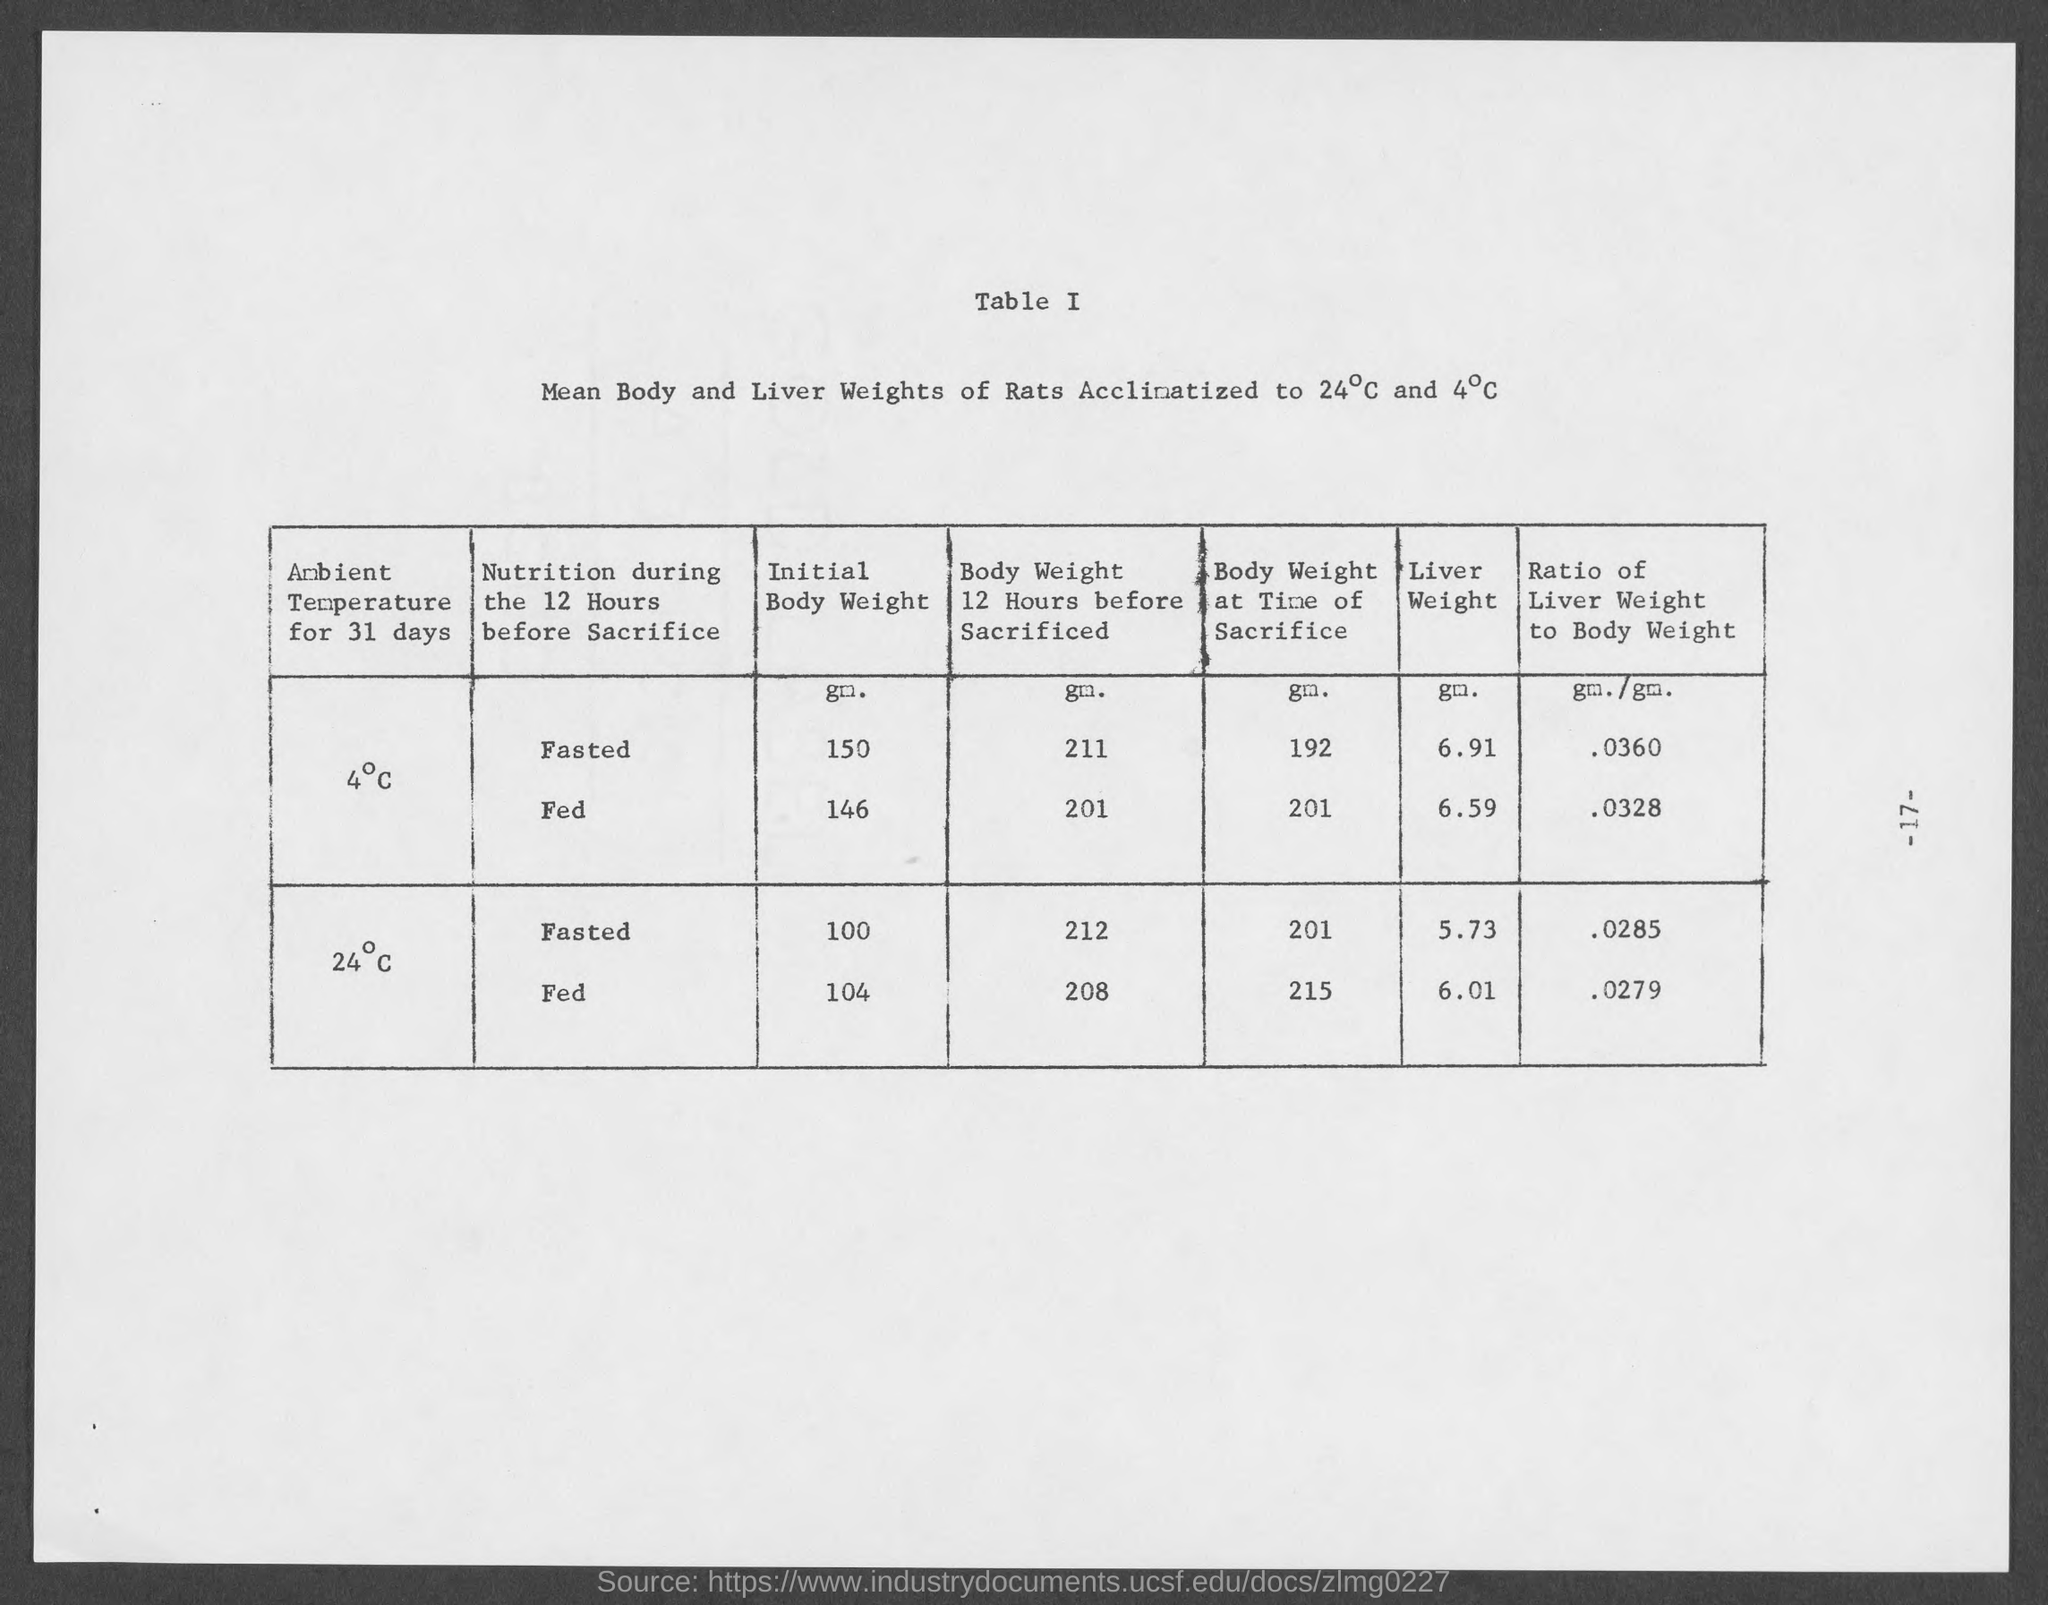Point out several critical features in this image. The initial body weight of rats fasted for 12 hours before sacrifice and acclimated to 4°C is 150 grams. The ratio of liver weight to body weight of rats fasted for 12 hours before sacrifice, and then stored at 4°C, was found to be approximately 0.0360 g/g. The weight of the liver of rats that were fasted for 12 hours before sacrifice and acclimated to 4°C is 6.91 grams. The initial body weight of rats fed 12 hours before sacrifice, acclimatized to 24°C, is 104 grams. The liver weight of rats fed for 12 hours before sacrifice, acclimated to 4°C, was 6.59 grams. 